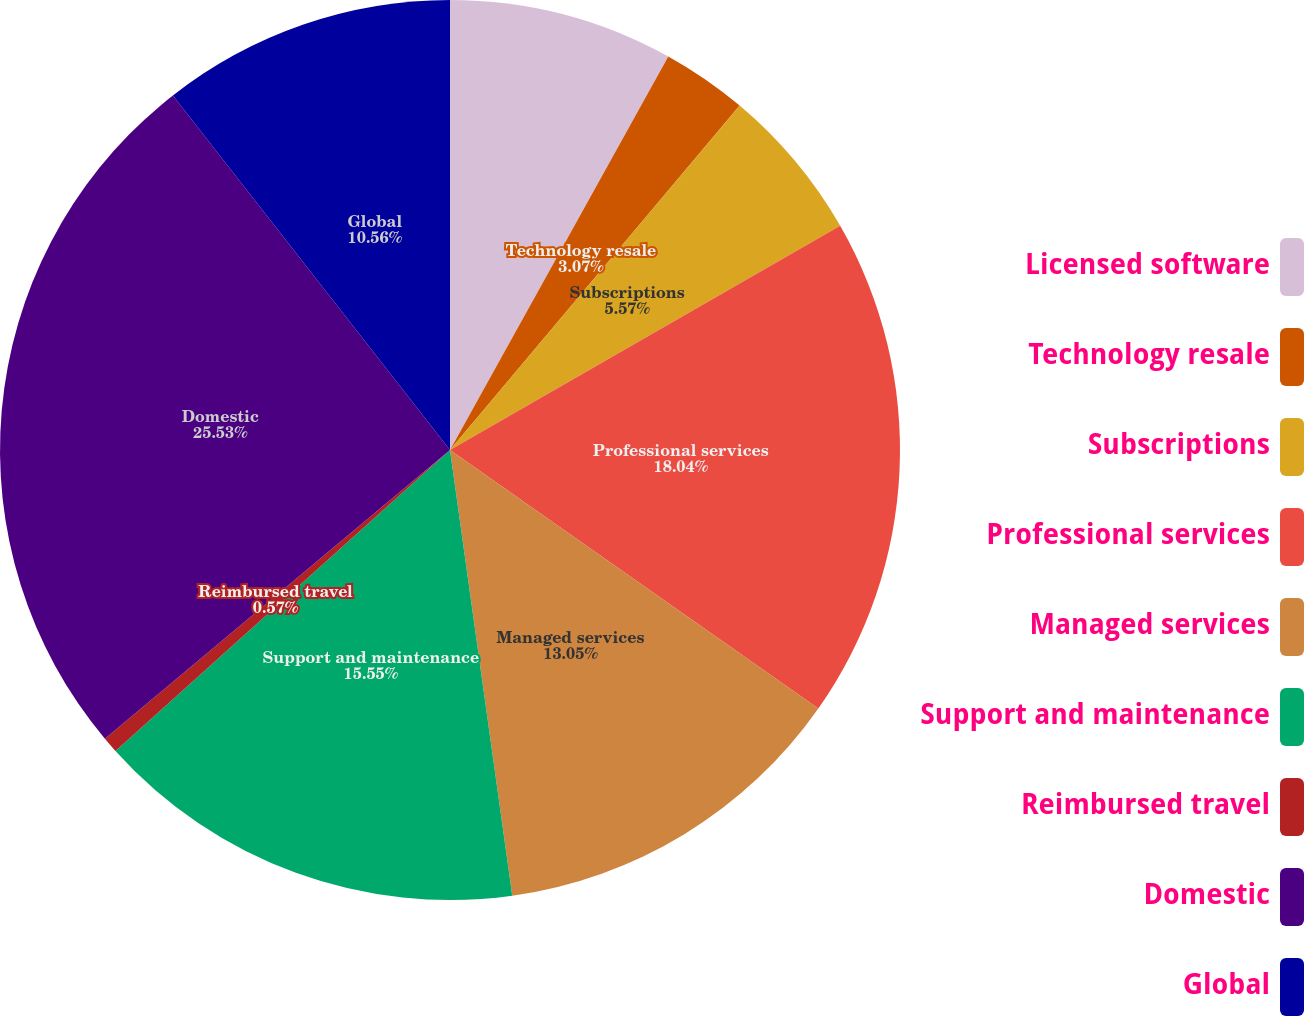<chart> <loc_0><loc_0><loc_500><loc_500><pie_chart><fcel>Licensed software<fcel>Technology resale<fcel>Subscriptions<fcel>Professional services<fcel>Managed services<fcel>Support and maintenance<fcel>Reimbursed travel<fcel>Domestic<fcel>Global<nl><fcel>8.06%<fcel>3.07%<fcel>5.57%<fcel>18.04%<fcel>13.05%<fcel>15.55%<fcel>0.57%<fcel>25.53%<fcel>10.56%<nl></chart> 